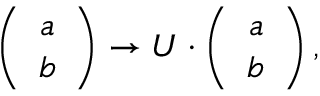<formula> <loc_0><loc_0><loc_500><loc_500>\left ( \begin{array} { c } { a } \\ { b } \end{array} \right ) \to U \cdot \left ( \begin{array} { c } { a } \\ { b } \end{array} \right ) ,</formula> 